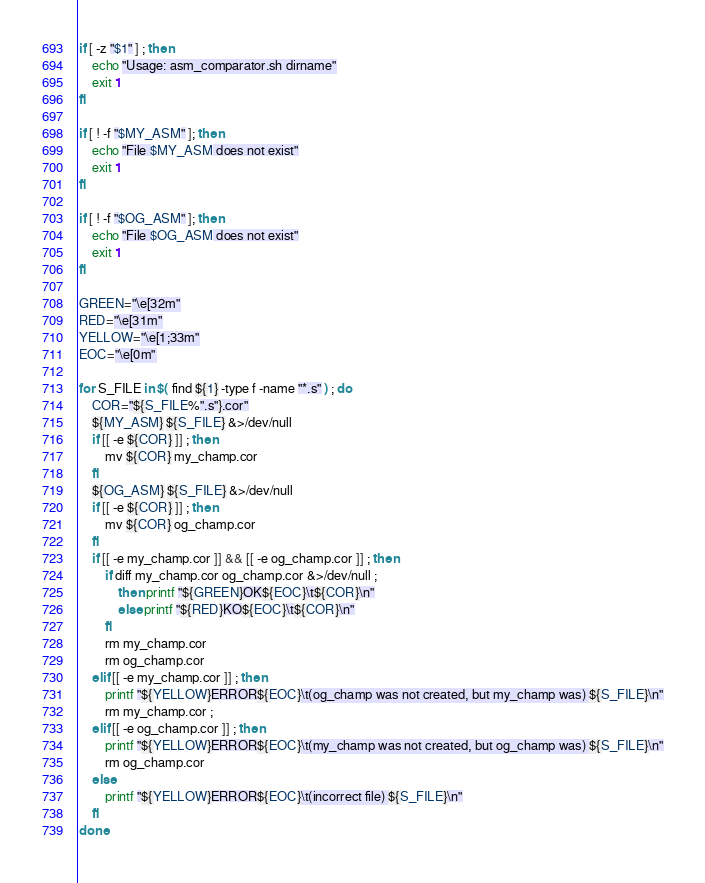Convert code to text. <code><loc_0><loc_0><loc_500><loc_500><_Bash_>
if [ -z "$1" ] ; then
	echo "Usage: asm_comparator.sh dirname"
	exit 1
fi

if [ ! -f "$MY_ASM" ]; then
	echo "File $MY_ASM does not exist"
	exit 1
fi

if [ ! -f "$OG_ASM" ]; then
	echo "File $OG_ASM does not exist"
	exit 1
fi

GREEN="\e[32m"
RED="\e[31m"
YELLOW="\e[1;33m"
EOC="\e[0m"

for S_FILE in $( find ${1} -type f -name "*.s" ) ; do
	COR="${S_FILE%".s"}.cor"
	${MY_ASM} ${S_FILE} &>/dev/null
	if [[ -e ${COR} ]] ; then
		mv ${COR} my_champ.cor
	fi
	${OG_ASM} ${S_FILE} &>/dev/null
	if [[ -e ${COR} ]] ; then
		mv ${COR} og_champ.cor
	fi
	if [[ -e my_champ.cor ]] && [[ -e og_champ.cor ]] ; then
		if diff my_champ.cor og_champ.cor &>/dev/null ;
			then printf "${GREEN}OK${EOC}\t${COR}\n"
			else printf "${RED}KO${EOC}\t${COR}\n"
		fi
		rm my_champ.cor
		rm og_champ.cor
	elif [[ -e my_champ.cor ]] ; then
		printf "${YELLOW}ERROR${EOC}\t(og_champ was not created, but my_champ was) ${S_FILE}\n"
		rm my_champ.cor ;
	elif [[ -e og_champ.cor ]] ; then
		printf "${YELLOW}ERROR${EOC}\t(my_champ was not created, but og_champ was) ${S_FILE}\n"
		rm og_champ.cor
	else
		printf "${YELLOW}ERROR${EOC}\t(incorrect file) ${S_FILE}\n"
	fi
done
</code> 